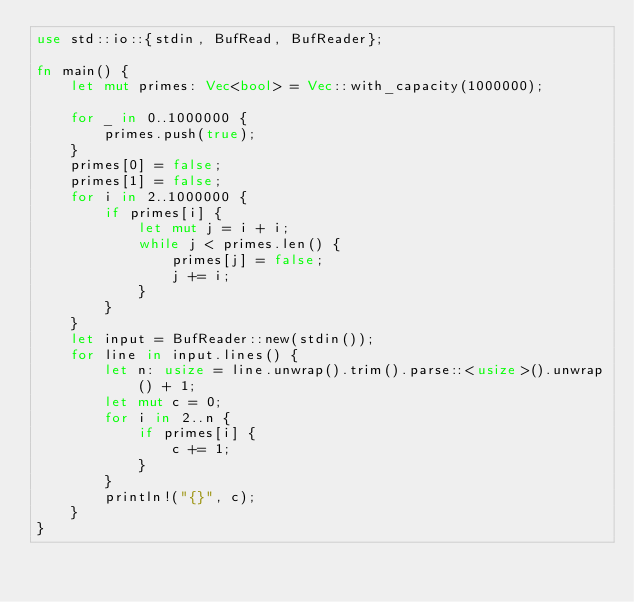<code> <loc_0><loc_0><loc_500><loc_500><_Rust_>use std::io::{stdin, BufRead, BufReader};

fn main() {
    let mut primes: Vec<bool> = Vec::with_capacity(1000000);

    for _ in 0..1000000 {
        primes.push(true);
    }
    primes[0] = false;
    primes[1] = false;
    for i in 2..1000000 {
        if primes[i] {
            let mut j = i + i;
            while j < primes.len() {
                primes[j] = false;
                j += i;
            }
        }
    }
    let input = BufReader::new(stdin());
    for line in input.lines() {
        let n: usize = line.unwrap().trim().parse::<usize>().unwrap() + 1;
        let mut c = 0;
        for i in 2..n {
            if primes[i] {
                c += 1;
            }
        }
        println!("{}", c);
    }
}

</code> 